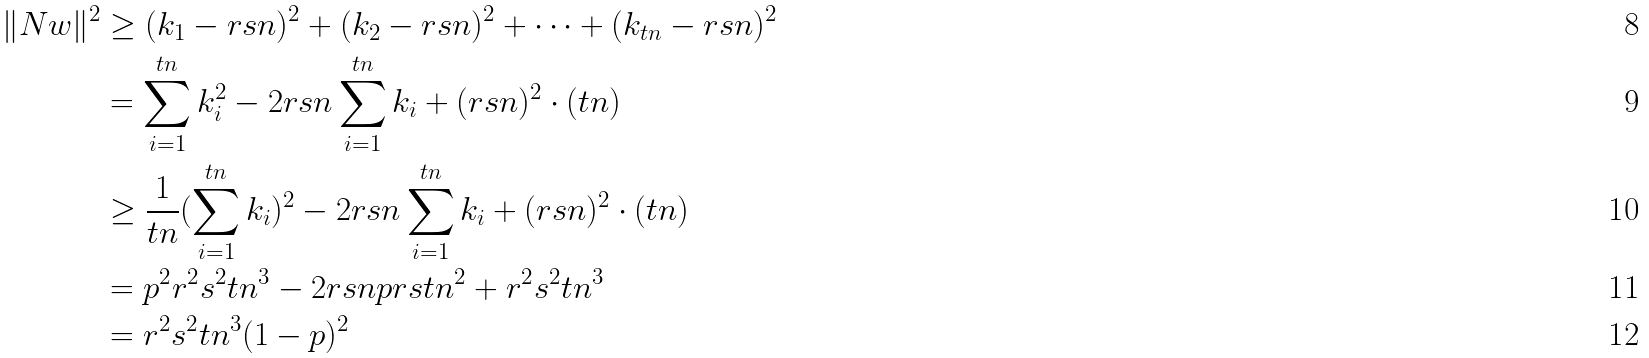<formula> <loc_0><loc_0><loc_500><loc_500>\| N w \| ^ { 2 } & \geq ( k _ { 1 } - r s n ) ^ { 2 } + ( k _ { 2 } - r s n ) ^ { 2 } + \dots + ( k _ { t n } - r s n ) ^ { 2 } \\ & = \sum _ { i = 1 } ^ { t n } k _ { i } ^ { 2 } - 2 r s n \sum _ { i = 1 } ^ { t n } k _ { i } + ( r s n ) ^ { 2 } \cdot ( t n ) \\ & \geq \frac { 1 } { t n } ( \sum _ { i = 1 } ^ { t n } k _ { i } ) ^ { 2 } - 2 r s n \sum _ { i = 1 } ^ { t n } k _ { i } + ( r s n ) ^ { 2 } \cdot ( t n ) \\ & = p ^ { 2 } r ^ { 2 } s ^ { 2 } t n ^ { 3 } - 2 r s n p r s t n ^ { 2 } + r ^ { 2 } s ^ { 2 } t n ^ { 3 } \\ & = r ^ { 2 } s ^ { 2 } t n ^ { 3 } ( 1 - p ) ^ { 2 }</formula> 